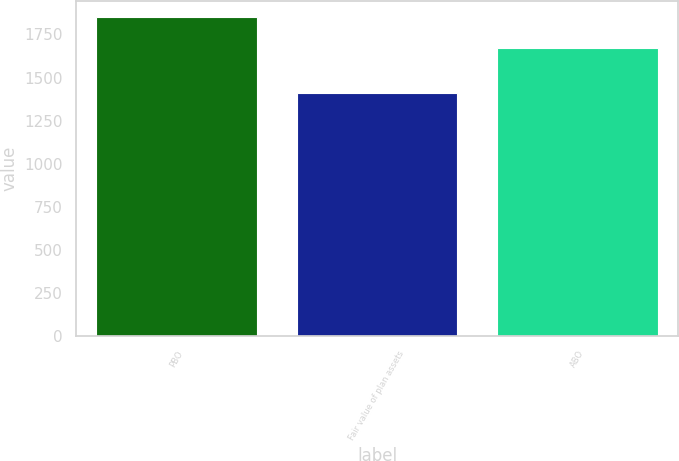Convert chart to OTSL. <chart><loc_0><loc_0><loc_500><loc_500><bar_chart><fcel>PBO<fcel>Fair value of plan assets<fcel>ABO<nl><fcel>1849.6<fcel>1411.1<fcel>1673.6<nl></chart> 